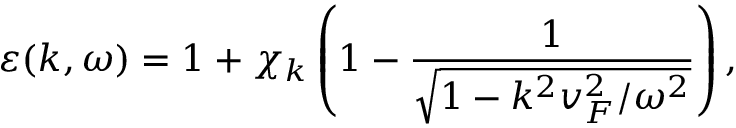<formula> <loc_0><loc_0><loc_500><loc_500>\varepsilon ( k , \omega ) = 1 + \chi _ { k } \left ( 1 - \frac { 1 } { \sqrt { 1 - k ^ { 2 } v _ { F } ^ { 2 } / \omega ^ { 2 } } } \right ) ,</formula> 